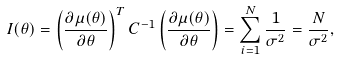<formula> <loc_0><loc_0><loc_500><loc_500>I ( \theta ) = \left ( { \frac { \partial { \mu } ( \theta ) } { \partial \theta } } \right ) ^ { T } { C } ^ { - 1 } \left ( { \frac { \partial { \mu } ( \theta ) } { \partial \theta } } \right ) = \sum _ { i = 1 } ^ { N } { \frac { 1 } { \sigma ^ { 2 } } } = { \frac { N } { \sigma ^ { 2 } } } ,</formula> 